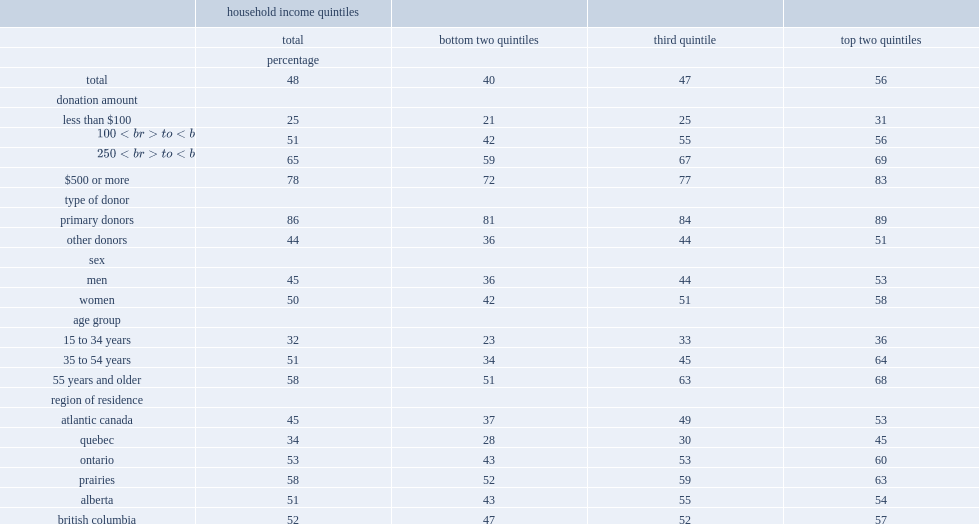How many percentage points did donors report that they planned on claiming a tax credit for the donations they made in the previous 12 months? 48.0. How many percentage points did donors give less than $100 planned on claiming a tax credit? 25.0. How many percentage points had donors given $500 or more in the previous 12 months? 78.0. How many percentage points did donors between 35 and 54 years whose household income was in the highest quintile plan on claiming a tax credit? 64.0. How many percentage points did donors between 35 and 54 years whose household income was in the bottom two quintiles plan on claiming a tax credit? 34.0. 